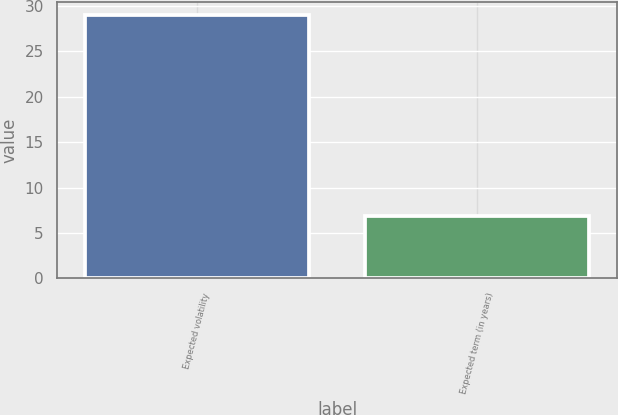<chart> <loc_0><loc_0><loc_500><loc_500><bar_chart><fcel>Expected volatility<fcel>Expected term (in years)<nl><fcel>29<fcel>6.9<nl></chart> 